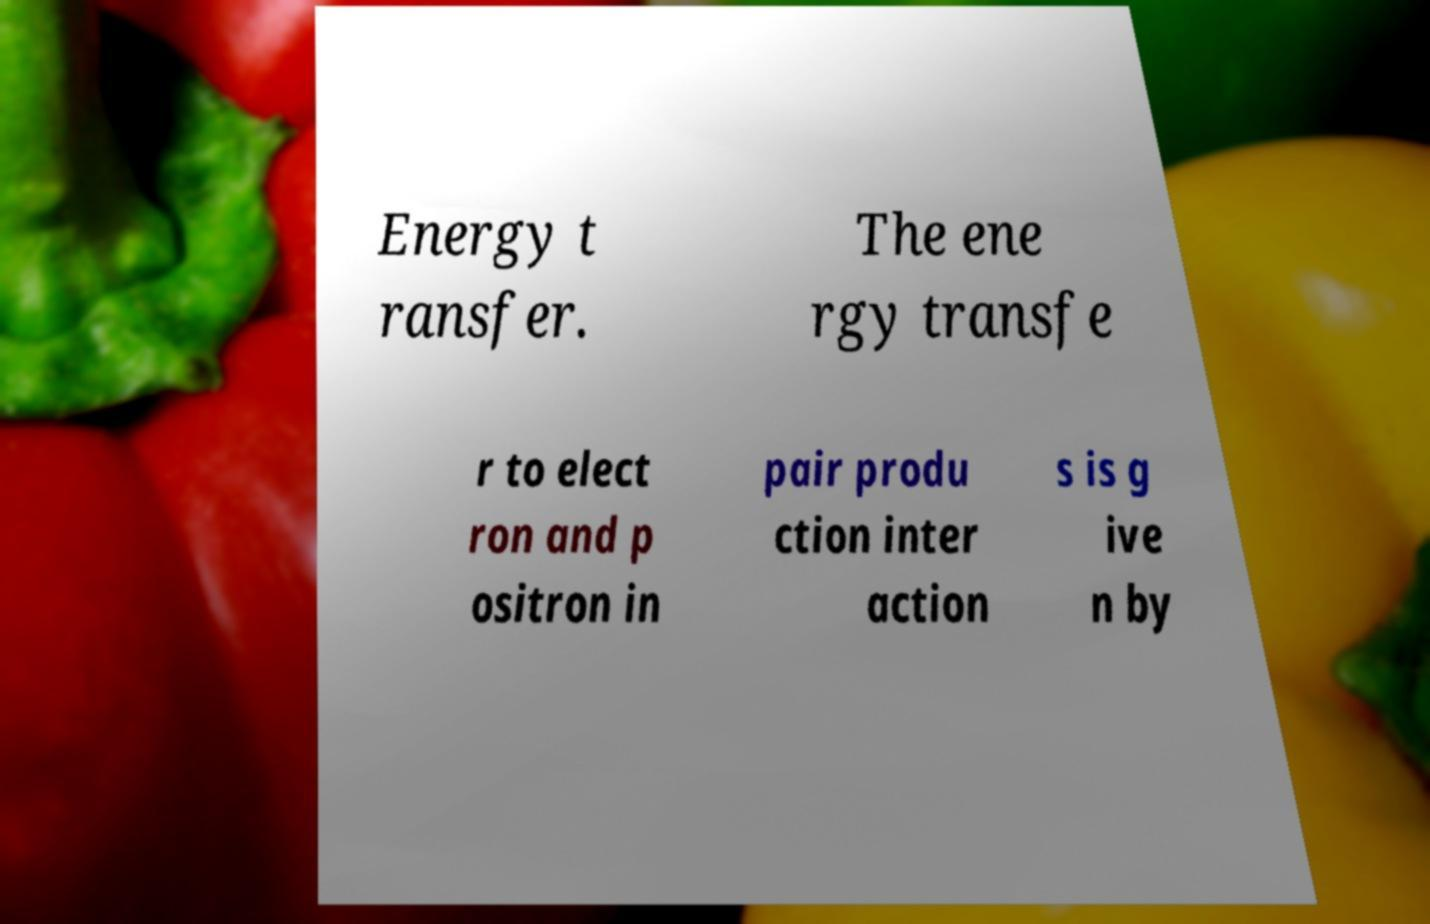What messages or text are displayed in this image? I need them in a readable, typed format. Energy t ransfer. The ene rgy transfe r to elect ron and p ositron in pair produ ction inter action s is g ive n by 